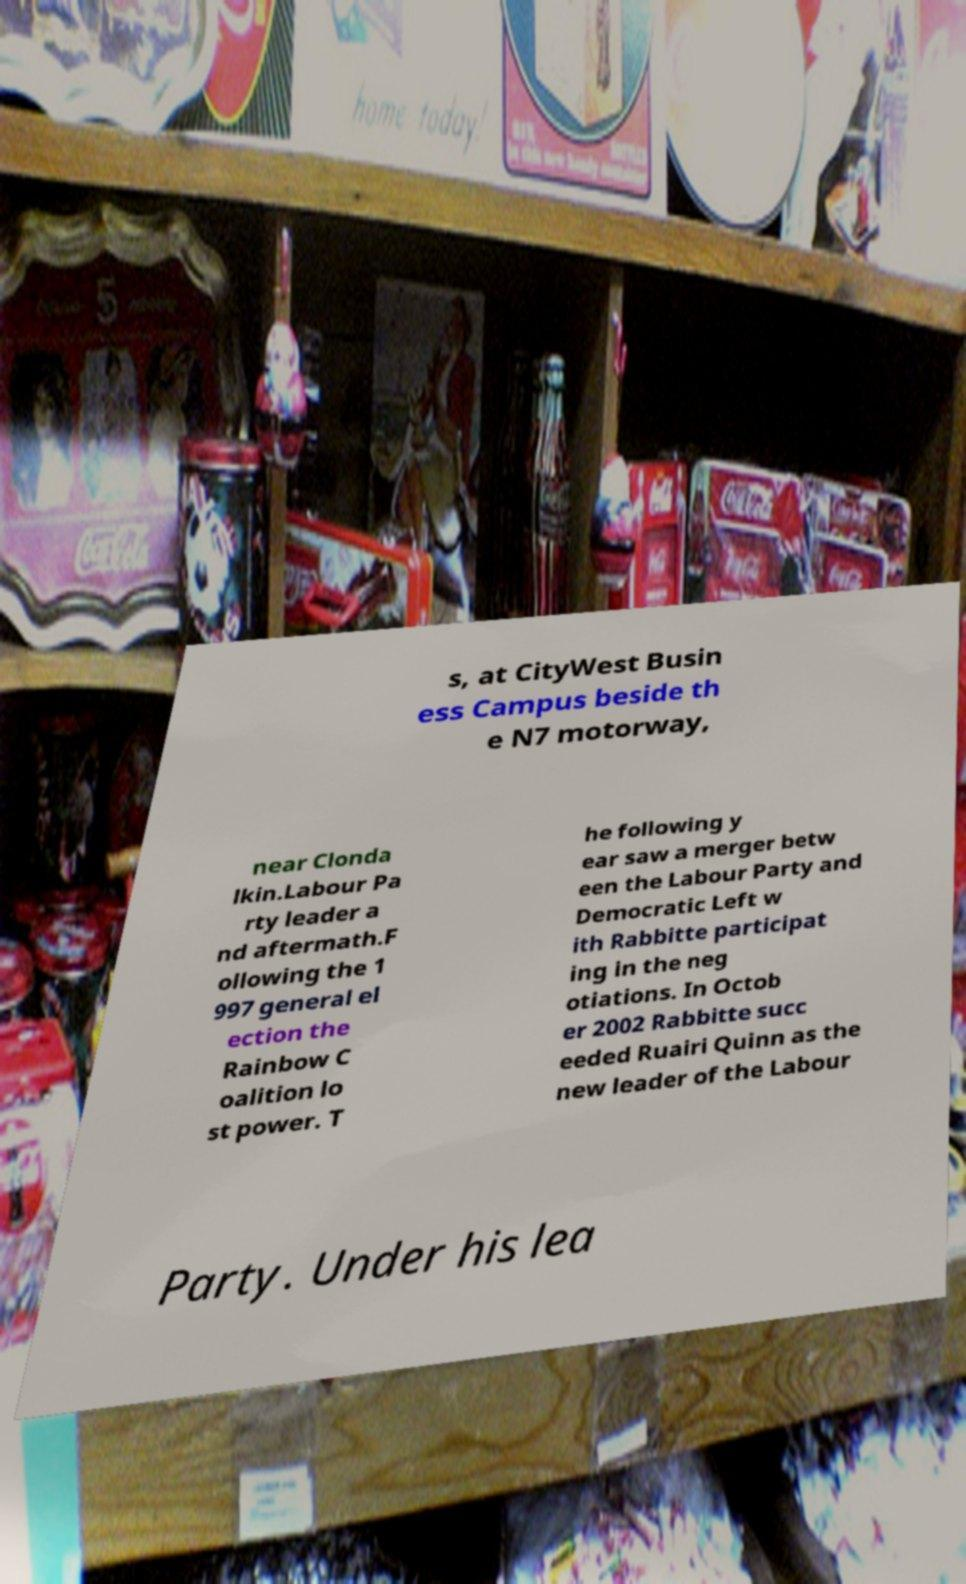For documentation purposes, I need the text within this image transcribed. Could you provide that? s, at CityWest Busin ess Campus beside th e N7 motorway, near Clonda lkin.Labour Pa rty leader a nd aftermath.F ollowing the 1 997 general el ection the Rainbow C oalition lo st power. T he following y ear saw a merger betw een the Labour Party and Democratic Left w ith Rabbitte participat ing in the neg otiations. In Octob er 2002 Rabbitte succ eeded Ruairi Quinn as the new leader of the Labour Party. Under his lea 